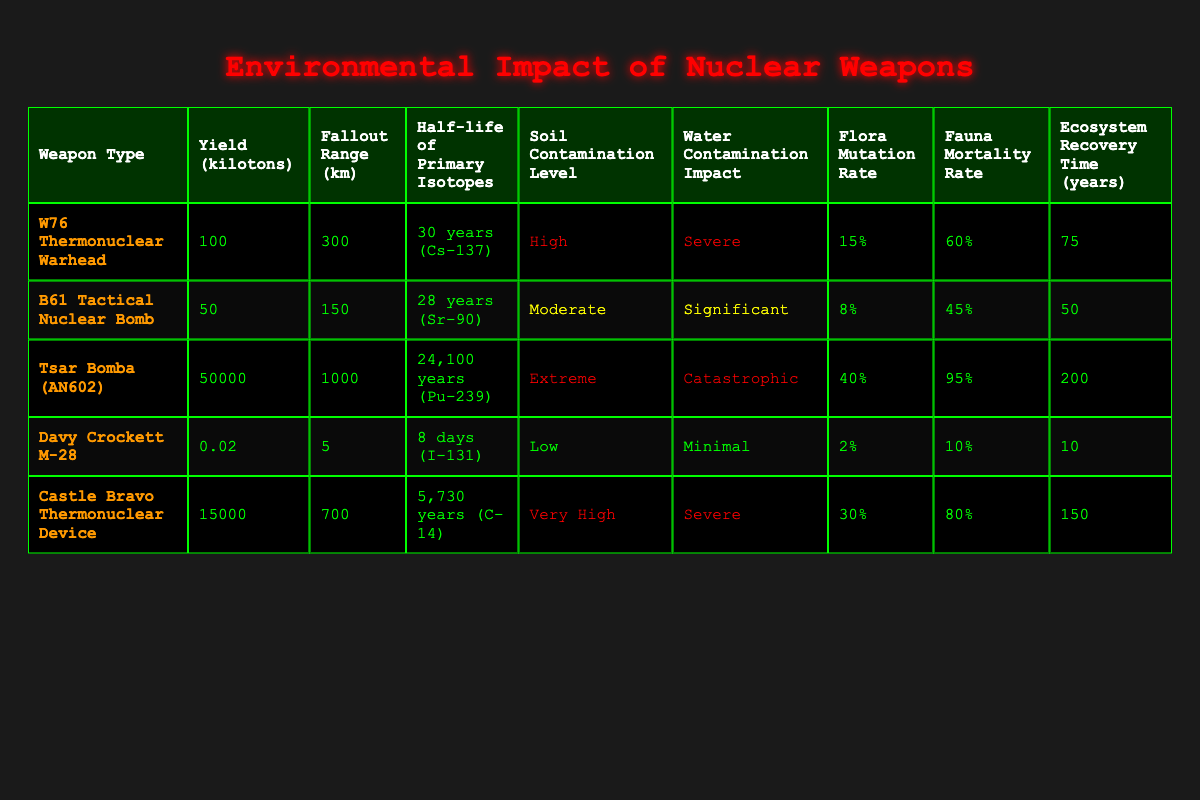What is the yield of the Tsar Bomba (AN602)? The yield of the Tsar Bomba (AN602) is explicitly listed in the table as 50000 kilotons.
Answer: 50000 kilotons How much is the fauna mortality rate for the B61 Tactical Nuclear Bomb? The fauna mortality rate for the B61 Tactical Nuclear Bomb is directly provided in the table as 45%.
Answer: 45% Which weapon has the highest soil contamination level? By comparing the soil contamination levels in the table, the weapon with the highest level is the Tsar Bomba (AN602), categorized as "Extreme."
Answer: Tsar Bomba (AN602) What is the average ecosytem recovery time for all weapon types listed? To find the average ecosystem recovery time, we sum the recovery times: 75 + 50 + 200 + 10 + 150 = 485 years. There are 5 weapons, so the average is 485/5 = 97 years.
Answer: 97 years Is it true that the Davy Crockett M-28 has a fallout range greater than 10 km? The fallout range for the Davy Crockett M-28 is listed as 5 km, which is less than 10 km, making this statement false.
Answer: No Which weapon type has a flora mutation rate greater than 30%? The table shows only the Tsar Bomba (AN602) has a flora mutation rate of 40%, which is greater than 30%. Therefore, the answer is Tsar Bomba (AN602).
Answer: Tsar Bomba (AN602) What is the difference in yield between the Castle Bravo Thermonuclear Device and the B61 Tactical Nuclear Bomb? The yield of Castle Bravo is 15000 kilotons, and the yield of B61 is 50 kilotons. The difference is 15000 - 50 = 14950 kilotons.
Answer: 14950 kilotons How long is the half-life of the primary isotopes in the W76 Thermonuclear Warhead? The half-life of the primary isotopes in the W76 Thermonuclear Warhead is stated in the table as 30 years (Cs-137).
Answer: 30 years (Cs-137) What is the water contamination impact level of the Castle Bravo Thermonuclear Device? The water contamination impact level for the Castle Bravo Thermonuclear Device is directly provided as "Severe" in the table.
Answer: Severe 